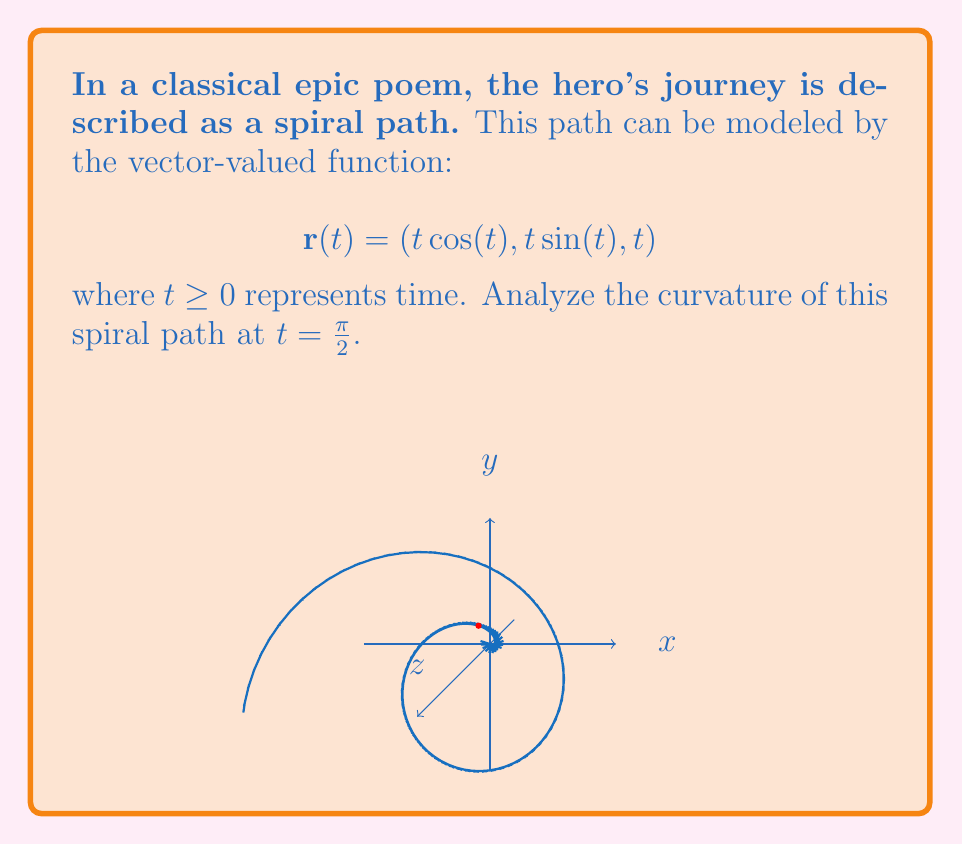Show me your answer to this math problem. To find the curvature of the spiral path, we'll use the formula:

$$\kappa = \frac{|\mathbf{r}'(t) \times \mathbf{r}''(t)|}{|\mathbf{r}'(t)|^3}$$

Step 1: Calculate $\mathbf{r}'(t)$
$$\mathbf{r}'(t) = (\cos(t) - t\sin(t), \sin(t) + t\cos(t), 1)$$

Step 2: Calculate $\mathbf{r}''(t)$
$$\mathbf{r}''(t) = (-2\sin(t) - t\cos(t), 2\cos(t) - t\sin(t), 0)$$

Step 3: Evaluate $\mathbf{r}'(\frac{\pi}{2})$ and $\mathbf{r}''(\frac{\pi}{2})$
$$\mathbf{r}'(\frac{\pi}{2}) = (-\frac{\pi}{2}, 1, 1)$$
$$\mathbf{r}''(\frac{\pi}{2}) = (-1, -\frac{\pi}{2}, 0)$$

Step 4: Calculate $\mathbf{r}'(\frac{\pi}{2}) \times \mathbf{r}''(\frac{\pi}{2})$
$$\mathbf{r}'(\frac{\pi}{2}) \times \mathbf{r}''(\frac{\pi}{2}) = \begin{vmatrix}
\mathbf{i} & \mathbf{j} & \mathbf{k} \\
-\frac{\pi}{2} & 1 & 1 \\
-1 & -\frac{\pi}{2} & 0
\end{vmatrix} = (-\frac{\pi}{2}, -1, \frac{\pi^2}{4} - 1)$$

Step 5: Calculate $|\mathbf{r}'(\frac{\pi}{2}) \times \mathbf{r}''(\frac{\pi}{2})|$
$$|\mathbf{r}'(\frac{\pi}{2}) \times \mathbf{r}''(\frac{\pi}{2})| = \sqrt{(\frac{\pi}{2})^2 + 1^2 + (\frac{\pi^2}{4} - 1)^2} = \sqrt{\frac{\pi^4}{16} + \frac{\pi^2}{2} + 2}$$

Step 6: Calculate $|\mathbf{r}'(\frac{\pi}{2})|^3$
$$|\mathbf{r}'(\frac{\pi}{2})|^3 = ((\frac{\pi}{2})^2 + 1^2 + 1^2)^{\frac{3}{2}} = (\frac{\pi^2}{4} + 2)^{\frac{3}{2}}$$

Step 7: Calculate the curvature $\kappa$
$$\kappa = \frac{\sqrt{\frac{\pi^4}{16} + \frac{\pi^2}{2} + 2}}{(\frac{\pi^2}{4} + 2)^{\frac{3}{2}}}$$
Answer: $\kappa = \frac{\sqrt{\frac{\pi^4}{16} + \frac{\pi^2}{2} + 2}}{(\frac{\pi^2}{4} + 2)^{\frac{3}{2}}}$ 